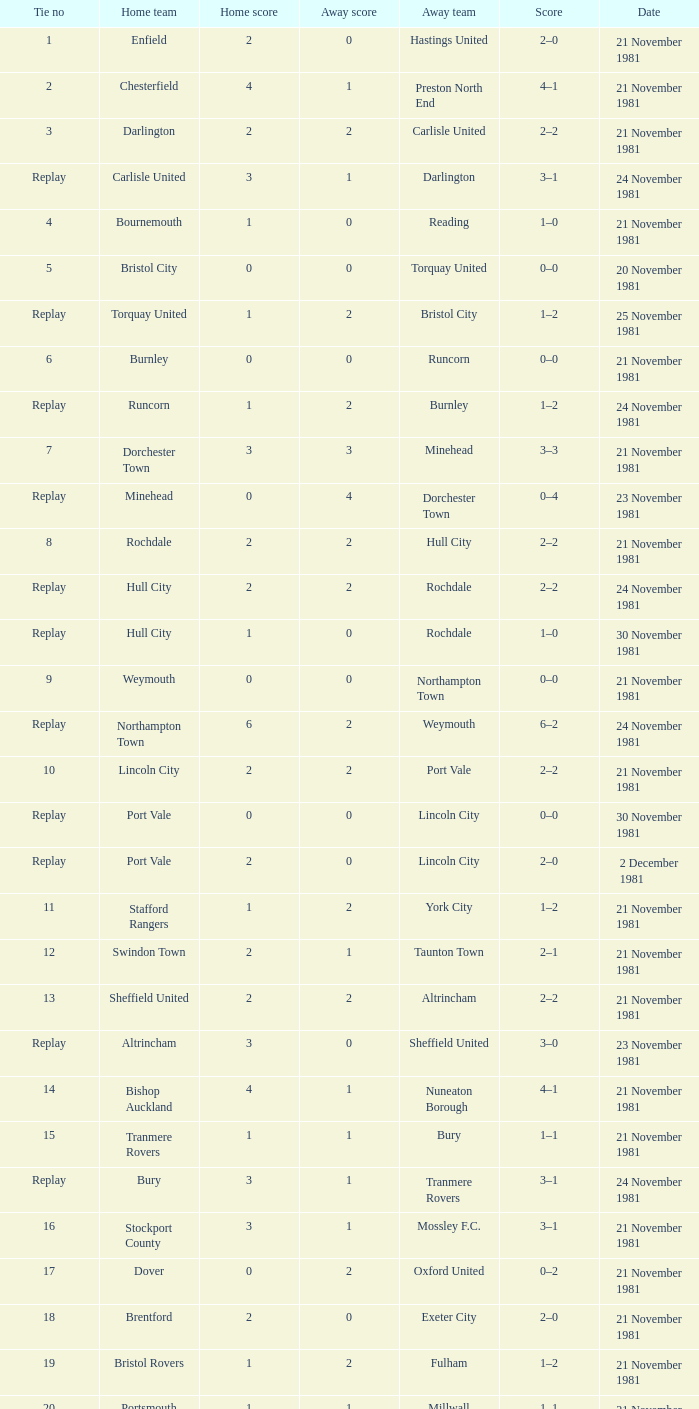What was the date for tie number 4? 21 November 1981. 